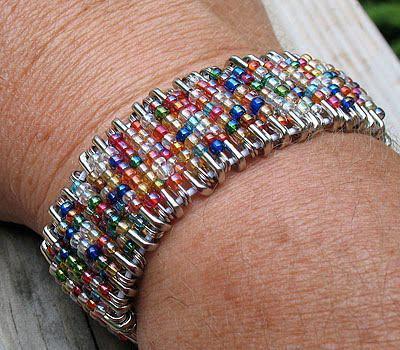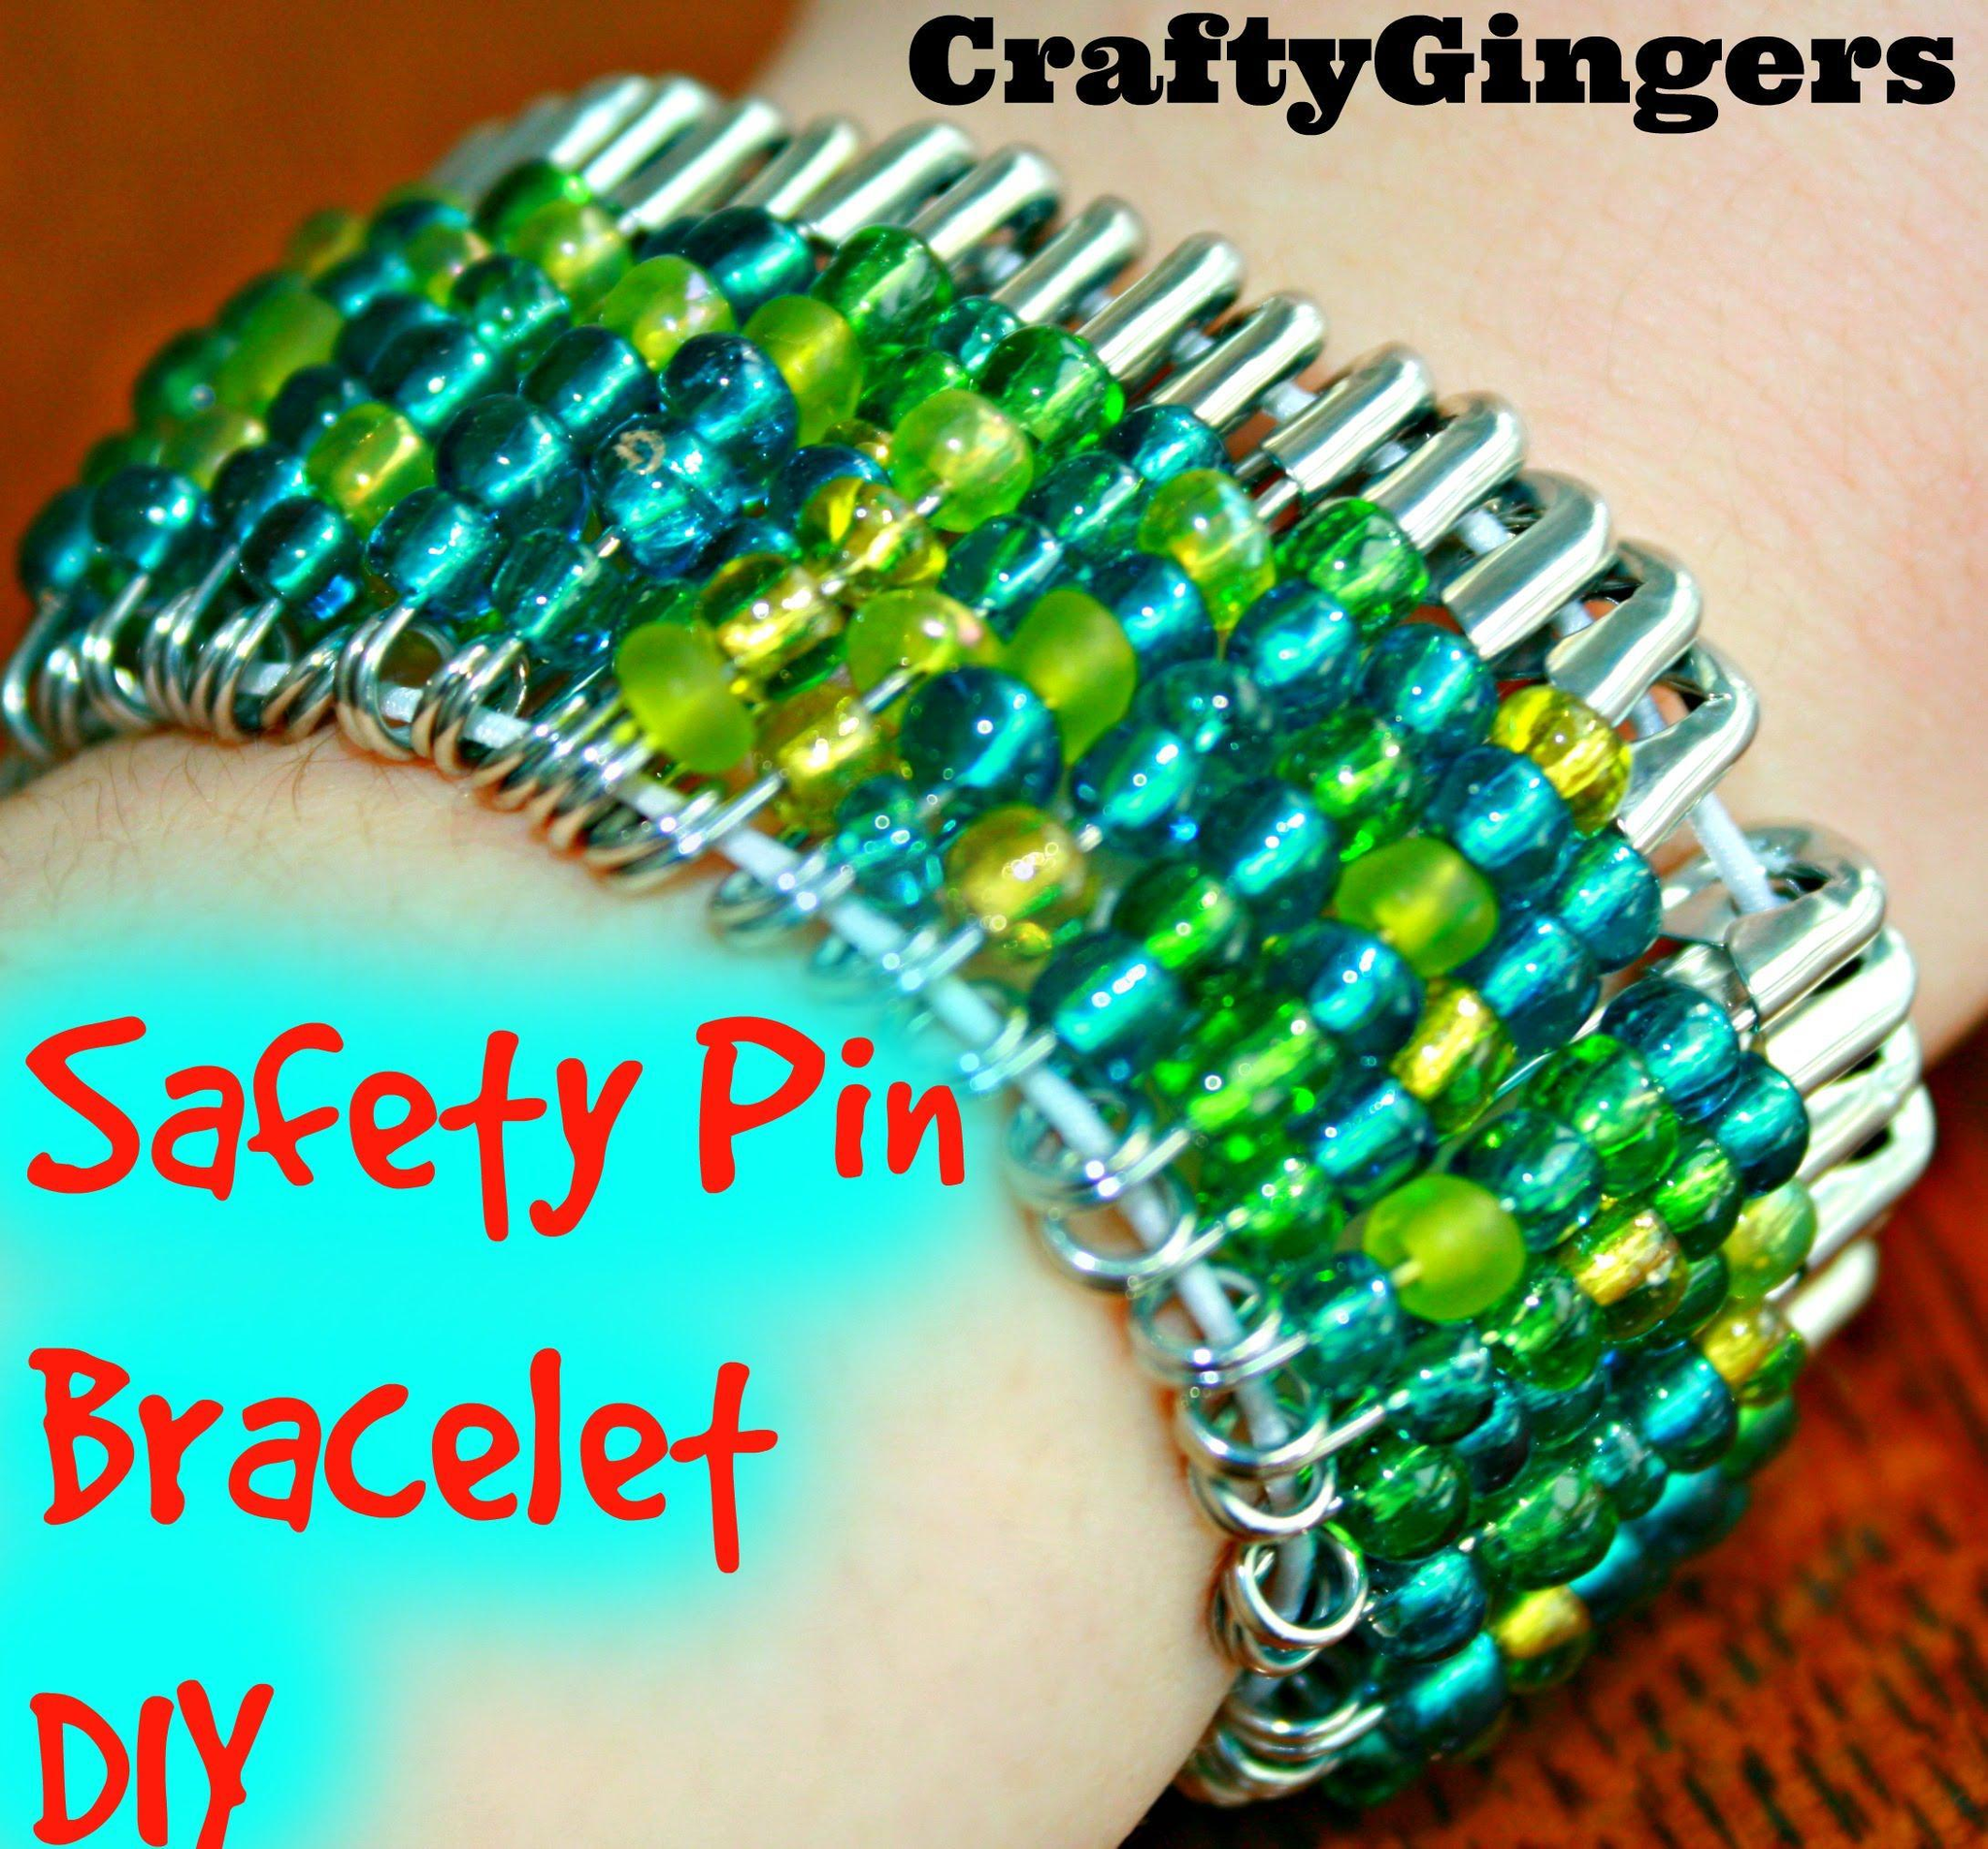The first image is the image on the left, the second image is the image on the right. Assess this claim about the two images: "A bracelet is being modeled in the image on the left.". Correct or not? Answer yes or no. Yes. The first image is the image on the left, the second image is the image on the right. For the images shown, is this caption "The left image contains a persons wrist modeling a bracelet with many beads." true? Answer yes or no. Yes. 